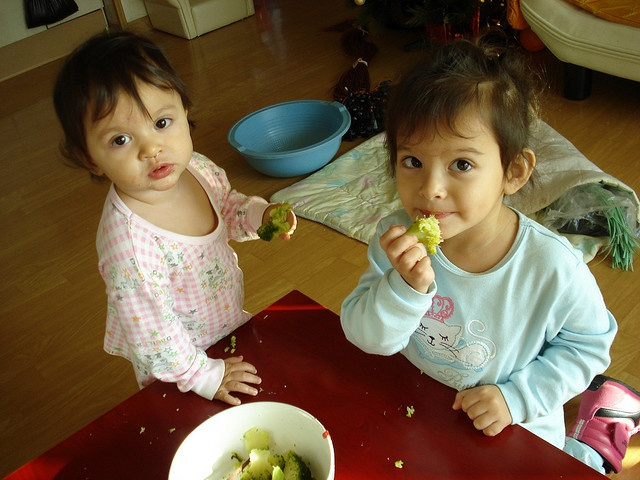Describe the objects in this image and their specific colors. I can see people in olive, lightblue, black, and darkgray tones, dining table in darkgreen, maroon, ivory, and beige tones, people in olive, lightgray, black, and tan tones, bowl in olive, ivory, beige, and tan tones, and bowl in olive, teal, and black tones in this image. 